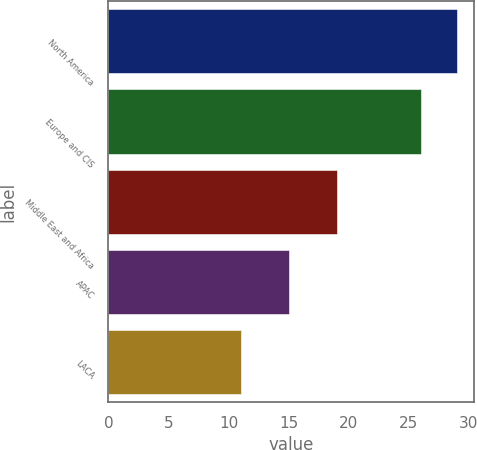Convert chart to OTSL. <chart><loc_0><loc_0><loc_500><loc_500><bar_chart><fcel>North America<fcel>Europe and CIS<fcel>Middle East and Africa<fcel>APAC<fcel>LACA<nl><fcel>29<fcel>26<fcel>19<fcel>15<fcel>11<nl></chart> 